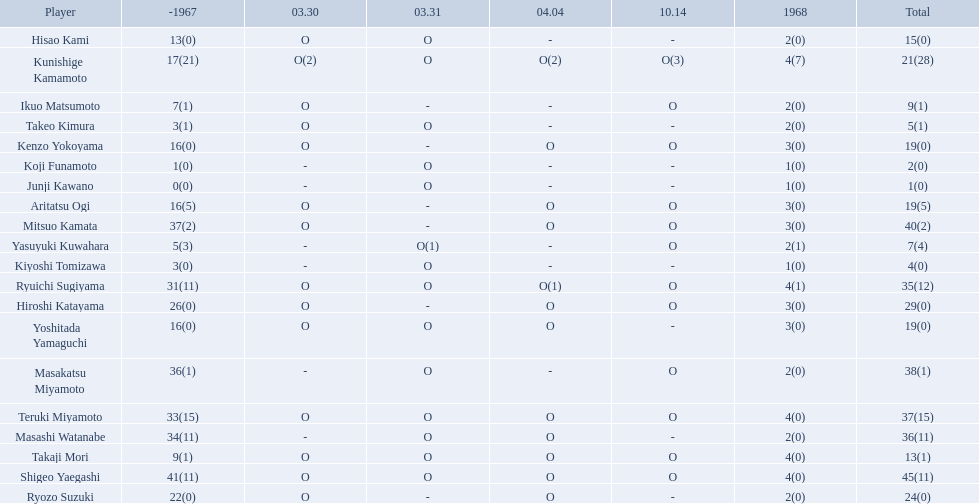Who were the players in the 1968 japanese football? Shigeo Yaegashi, Mitsuo Kamata, Masakatsu Miyamoto, Masashi Watanabe, Teruki Miyamoto, Ryuichi Sugiyama, Hiroshi Katayama, Ryozo Suzuki, Kunishige Kamamoto, Aritatsu Ogi, Yoshitada Yamaguchi, Kenzo Yokoyama, Hisao Kami, Takaji Mori, Ikuo Matsumoto, Yasuyuki Kuwahara, Takeo Kimura, Kiyoshi Tomizawa, Koji Funamoto, Junji Kawano. How many points total did takaji mori have? 13(1). How many points total did junju kawano? 1(0). Who had more points? Takaji Mori. 